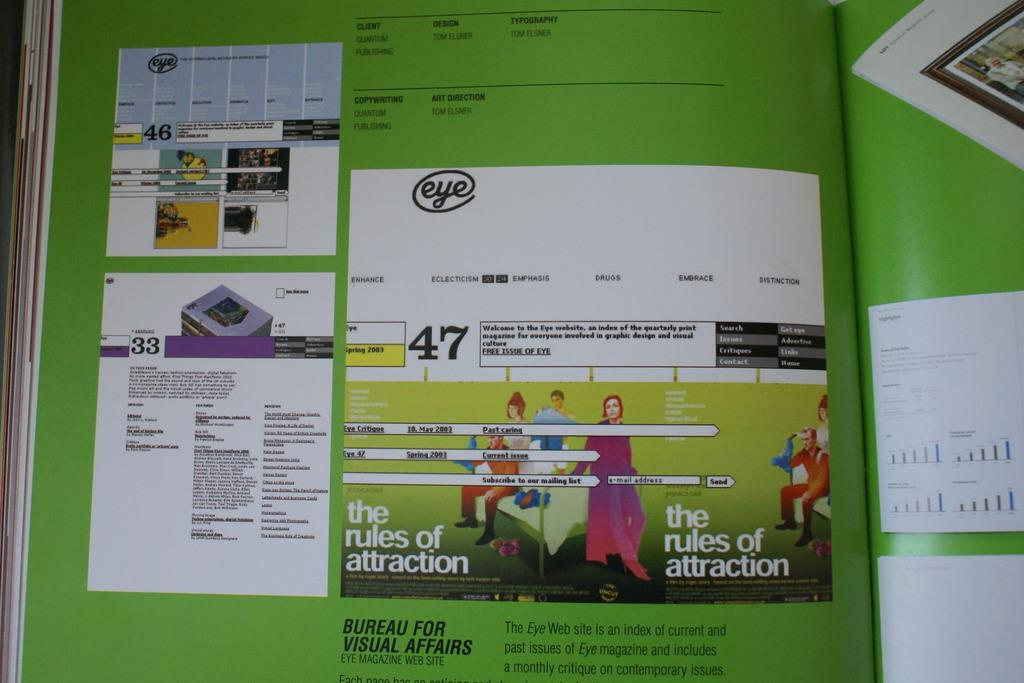<image>
Render a clear and concise summary of the photo. A magazine is opened to a page in green with test at the bottom that says "Bureau for Visual Affairs." 